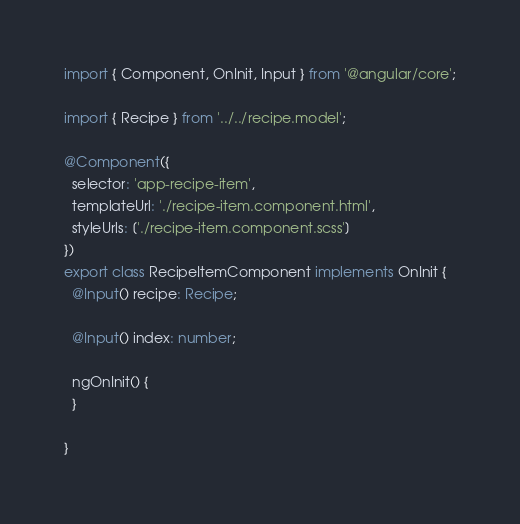<code> <loc_0><loc_0><loc_500><loc_500><_TypeScript_>import { Component, OnInit, Input } from '@angular/core';

import { Recipe } from '../../recipe.model';

@Component({
  selector: 'app-recipe-item',
  templateUrl: './recipe-item.component.html',
  styleUrls: ['./recipe-item.component.scss']
})
export class RecipeItemComponent implements OnInit {
  @Input() recipe: Recipe;

  @Input() index: number;

  ngOnInit() {
  }

}
</code> 